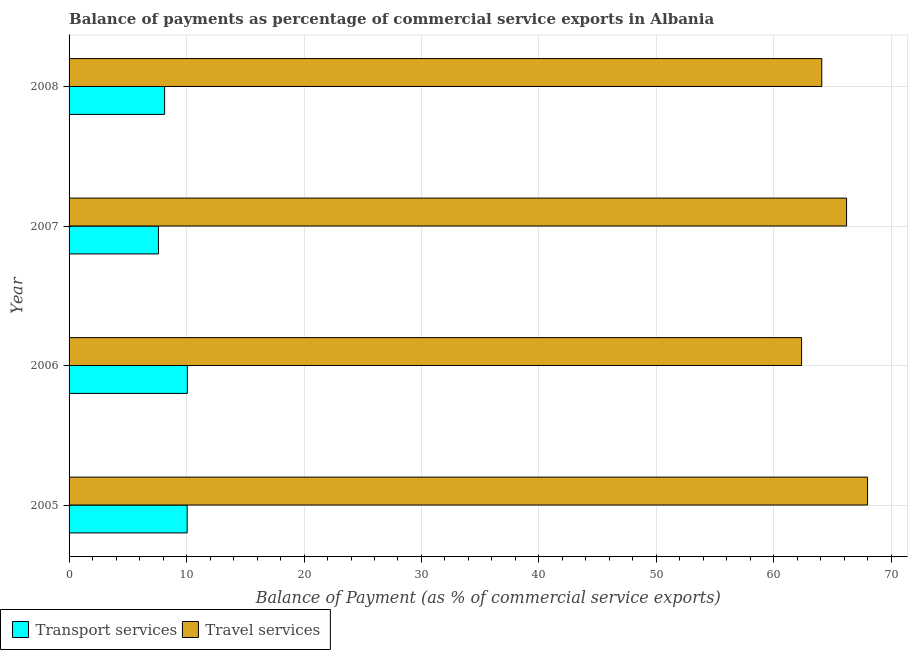How many different coloured bars are there?
Your answer should be very brief. 2. Are the number of bars on each tick of the Y-axis equal?
Provide a succinct answer. Yes. How many bars are there on the 4th tick from the bottom?
Provide a succinct answer. 2. In how many cases, is the number of bars for a given year not equal to the number of legend labels?
Provide a short and direct response. 0. What is the balance of payments of transport services in 2008?
Provide a succinct answer. 8.13. Across all years, what is the maximum balance of payments of travel services?
Give a very brief answer. 67.97. Across all years, what is the minimum balance of payments of travel services?
Provide a short and direct response. 62.36. In which year was the balance of payments of transport services maximum?
Ensure brevity in your answer.  2006. What is the total balance of payments of transport services in the graph?
Give a very brief answer. 35.87. What is the difference between the balance of payments of travel services in 2006 and that in 2008?
Your answer should be very brief. -1.72. What is the difference between the balance of payments of travel services in 2008 and the balance of payments of transport services in 2005?
Offer a very short reply. 54.02. What is the average balance of payments of transport services per year?
Provide a succinct answer. 8.97. In the year 2005, what is the difference between the balance of payments of travel services and balance of payments of transport services?
Your response must be concise. 57.92. What is the ratio of the balance of payments of transport services in 2006 to that in 2008?
Offer a terse response. 1.24. Is the balance of payments of travel services in 2006 less than that in 2008?
Keep it short and to the point. Yes. Is the difference between the balance of payments of transport services in 2006 and 2008 greater than the difference between the balance of payments of travel services in 2006 and 2008?
Give a very brief answer. Yes. What is the difference between the highest and the second highest balance of payments of transport services?
Offer a very short reply. 0.02. What is the difference between the highest and the lowest balance of payments of travel services?
Keep it short and to the point. 5.62. In how many years, is the balance of payments of transport services greater than the average balance of payments of transport services taken over all years?
Your answer should be compact. 2. Is the sum of the balance of payments of travel services in 2005 and 2006 greater than the maximum balance of payments of transport services across all years?
Your answer should be compact. Yes. What does the 1st bar from the top in 2007 represents?
Give a very brief answer. Travel services. What does the 1st bar from the bottom in 2008 represents?
Give a very brief answer. Transport services. How many bars are there?
Your response must be concise. 8. How many years are there in the graph?
Make the answer very short. 4. Are the values on the major ticks of X-axis written in scientific E-notation?
Make the answer very short. No. How many legend labels are there?
Provide a short and direct response. 2. How are the legend labels stacked?
Provide a succinct answer. Horizontal. What is the title of the graph?
Give a very brief answer. Balance of payments as percentage of commercial service exports in Albania. What is the label or title of the X-axis?
Give a very brief answer. Balance of Payment (as % of commercial service exports). What is the Balance of Payment (as % of commercial service exports) of Transport services in 2005?
Make the answer very short. 10.05. What is the Balance of Payment (as % of commercial service exports) of Travel services in 2005?
Your answer should be very brief. 67.97. What is the Balance of Payment (as % of commercial service exports) in Transport services in 2006?
Your answer should be compact. 10.07. What is the Balance of Payment (as % of commercial service exports) in Travel services in 2006?
Provide a succinct answer. 62.36. What is the Balance of Payment (as % of commercial service exports) of Transport services in 2007?
Keep it short and to the point. 7.61. What is the Balance of Payment (as % of commercial service exports) in Travel services in 2007?
Provide a short and direct response. 66.18. What is the Balance of Payment (as % of commercial service exports) of Transport services in 2008?
Offer a terse response. 8.13. What is the Balance of Payment (as % of commercial service exports) in Travel services in 2008?
Your answer should be compact. 64.08. Across all years, what is the maximum Balance of Payment (as % of commercial service exports) in Transport services?
Provide a short and direct response. 10.07. Across all years, what is the maximum Balance of Payment (as % of commercial service exports) in Travel services?
Offer a very short reply. 67.97. Across all years, what is the minimum Balance of Payment (as % of commercial service exports) in Transport services?
Provide a short and direct response. 7.61. Across all years, what is the minimum Balance of Payment (as % of commercial service exports) of Travel services?
Provide a succinct answer. 62.36. What is the total Balance of Payment (as % of commercial service exports) of Transport services in the graph?
Keep it short and to the point. 35.87. What is the total Balance of Payment (as % of commercial service exports) in Travel services in the graph?
Give a very brief answer. 260.59. What is the difference between the Balance of Payment (as % of commercial service exports) of Transport services in 2005 and that in 2006?
Give a very brief answer. -0.02. What is the difference between the Balance of Payment (as % of commercial service exports) in Travel services in 2005 and that in 2006?
Offer a very short reply. 5.62. What is the difference between the Balance of Payment (as % of commercial service exports) of Transport services in 2005 and that in 2007?
Offer a very short reply. 2.44. What is the difference between the Balance of Payment (as % of commercial service exports) in Travel services in 2005 and that in 2007?
Give a very brief answer. 1.79. What is the difference between the Balance of Payment (as % of commercial service exports) of Transport services in 2005 and that in 2008?
Provide a succinct answer. 1.92. What is the difference between the Balance of Payment (as % of commercial service exports) of Travel services in 2005 and that in 2008?
Offer a very short reply. 3.9. What is the difference between the Balance of Payment (as % of commercial service exports) in Transport services in 2006 and that in 2007?
Keep it short and to the point. 2.46. What is the difference between the Balance of Payment (as % of commercial service exports) of Travel services in 2006 and that in 2007?
Provide a short and direct response. -3.83. What is the difference between the Balance of Payment (as % of commercial service exports) in Transport services in 2006 and that in 2008?
Your answer should be compact. 1.94. What is the difference between the Balance of Payment (as % of commercial service exports) of Travel services in 2006 and that in 2008?
Ensure brevity in your answer.  -1.72. What is the difference between the Balance of Payment (as % of commercial service exports) in Transport services in 2007 and that in 2008?
Your answer should be compact. -0.53. What is the difference between the Balance of Payment (as % of commercial service exports) in Travel services in 2007 and that in 2008?
Provide a short and direct response. 2.11. What is the difference between the Balance of Payment (as % of commercial service exports) in Transport services in 2005 and the Balance of Payment (as % of commercial service exports) in Travel services in 2006?
Provide a succinct answer. -52.31. What is the difference between the Balance of Payment (as % of commercial service exports) of Transport services in 2005 and the Balance of Payment (as % of commercial service exports) of Travel services in 2007?
Provide a succinct answer. -56.13. What is the difference between the Balance of Payment (as % of commercial service exports) of Transport services in 2005 and the Balance of Payment (as % of commercial service exports) of Travel services in 2008?
Provide a succinct answer. -54.02. What is the difference between the Balance of Payment (as % of commercial service exports) of Transport services in 2006 and the Balance of Payment (as % of commercial service exports) of Travel services in 2007?
Provide a short and direct response. -56.11. What is the difference between the Balance of Payment (as % of commercial service exports) of Transport services in 2006 and the Balance of Payment (as % of commercial service exports) of Travel services in 2008?
Offer a terse response. -54.01. What is the difference between the Balance of Payment (as % of commercial service exports) of Transport services in 2007 and the Balance of Payment (as % of commercial service exports) of Travel services in 2008?
Provide a short and direct response. -56.47. What is the average Balance of Payment (as % of commercial service exports) of Transport services per year?
Provide a succinct answer. 8.97. What is the average Balance of Payment (as % of commercial service exports) in Travel services per year?
Your answer should be very brief. 65.15. In the year 2005, what is the difference between the Balance of Payment (as % of commercial service exports) of Transport services and Balance of Payment (as % of commercial service exports) of Travel services?
Your answer should be compact. -57.92. In the year 2006, what is the difference between the Balance of Payment (as % of commercial service exports) in Transport services and Balance of Payment (as % of commercial service exports) in Travel services?
Your answer should be very brief. -52.29. In the year 2007, what is the difference between the Balance of Payment (as % of commercial service exports) of Transport services and Balance of Payment (as % of commercial service exports) of Travel services?
Your response must be concise. -58.58. In the year 2008, what is the difference between the Balance of Payment (as % of commercial service exports) in Transport services and Balance of Payment (as % of commercial service exports) in Travel services?
Your answer should be compact. -55.94. What is the ratio of the Balance of Payment (as % of commercial service exports) in Transport services in 2005 to that in 2006?
Provide a short and direct response. 1. What is the ratio of the Balance of Payment (as % of commercial service exports) of Travel services in 2005 to that in 2006?
Offer a very short reply. 1.09. What is the ratio of the Balance of Payment (as % of commercial service exports) of Transport services in 2005 to that in 2007?
Offer a very short reply. 1.32. What is the ratio of the Balance of Payment (as % of commercial service exports) in Transport services in 2005 to that in 2008?
Keep it short and to the point. 1.24. What is the ratio of the Balance of Payment (as % of commercial service exports) in Travel services in 2005 to that in 2008?
Keep it short and to the point. 1.06. What is the ratio of the Balance of Payment (as % of commercial service exports) in Transport services in 2006 to that in 2007?
Provide a short and direct response. 1.32. What is the ratio of the Balance of Payment (as % of commercial service exports) in Travel services in 2006 to that in 2007?
Make the answer very short. 0.94. What is the ratio of the Balance of Payment (as % of commercial service exports) of Transport services in 2006 to that in 2008?
Your answer should be very brief. 1.24. What is the ratio of the Balance of Payment (as % of commercial service exports) in Travel services in 2006 to that in 2008?
Your answer should be very brief. 0.97. What is the ratio of the Balance of Payment (as % of commercial service exports) in Transport services in 2007 to that in 2008?
Offer a terse response. 0.94. What is the ratio of the Balance of Payment (as % of commercial service exports) in Travel services in 2007 to that in 2008?
Offer a very short reply. 1.03. What is the difference between the highest and the second highest Balance of Payment (as % of commercial service exports) in Transport services?
Your answer should be very brief. 0.02. What is the difference between the highest and the second highest Balance of Payment (as % of commercial service exports) in Travel services?
Provide a short and direct response. 1.79. What is the difference between the highest and the lowest Balance of Payment (as % of commercial service exports) in Transport services?
Your response must be concise. 2.46. What is the difference between the highest and the lowest Balance of Payment (as % of commercial service exports) of Travel services?
Provide a succinct answer. 5.62. 